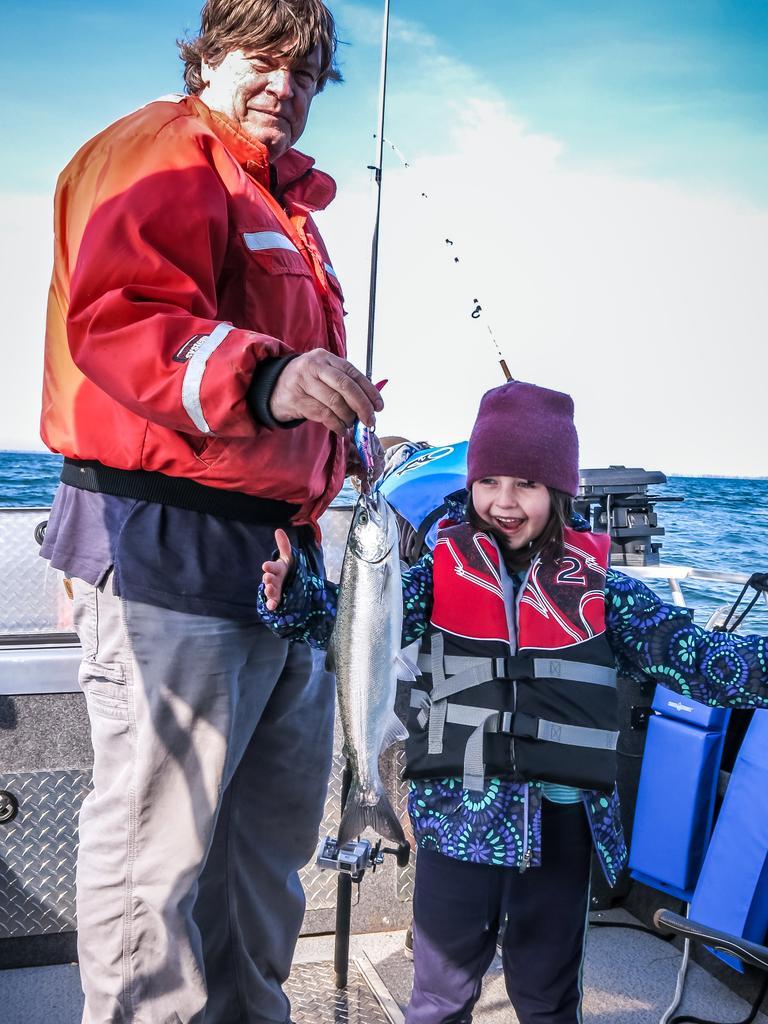Could you give a brief overview of what you see in this image? There is a man standing and smiling and holding a fishing rod with fish, in front of him there is a girl standing and smiling. We can see boat and water. In the background we can see sky with clouds. 